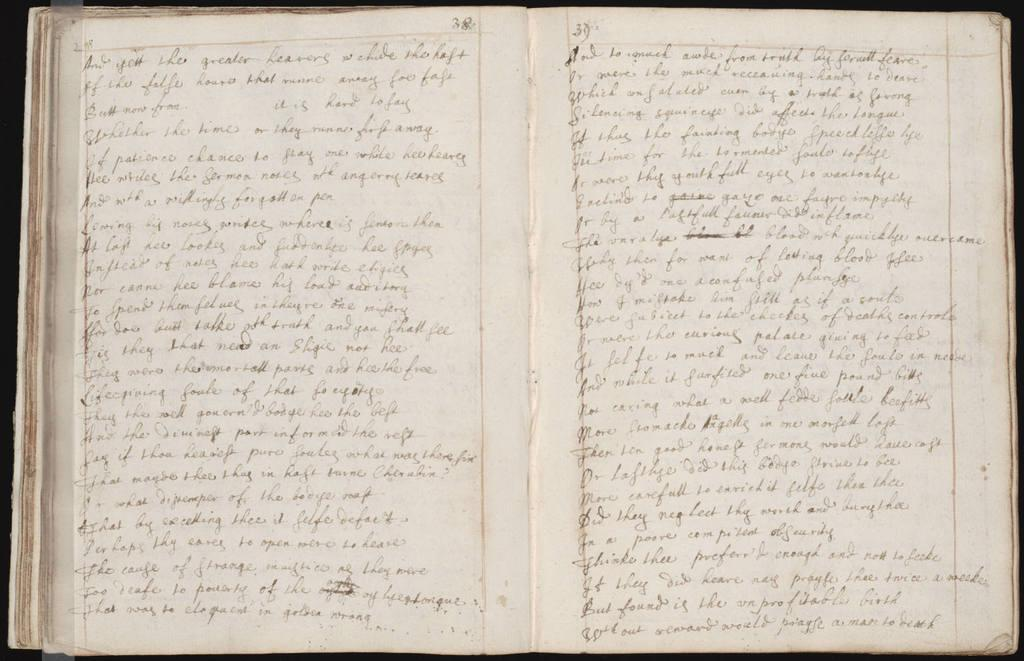Provide a one-sentence caption for the provided image. The first word on the page of an open book is and. 